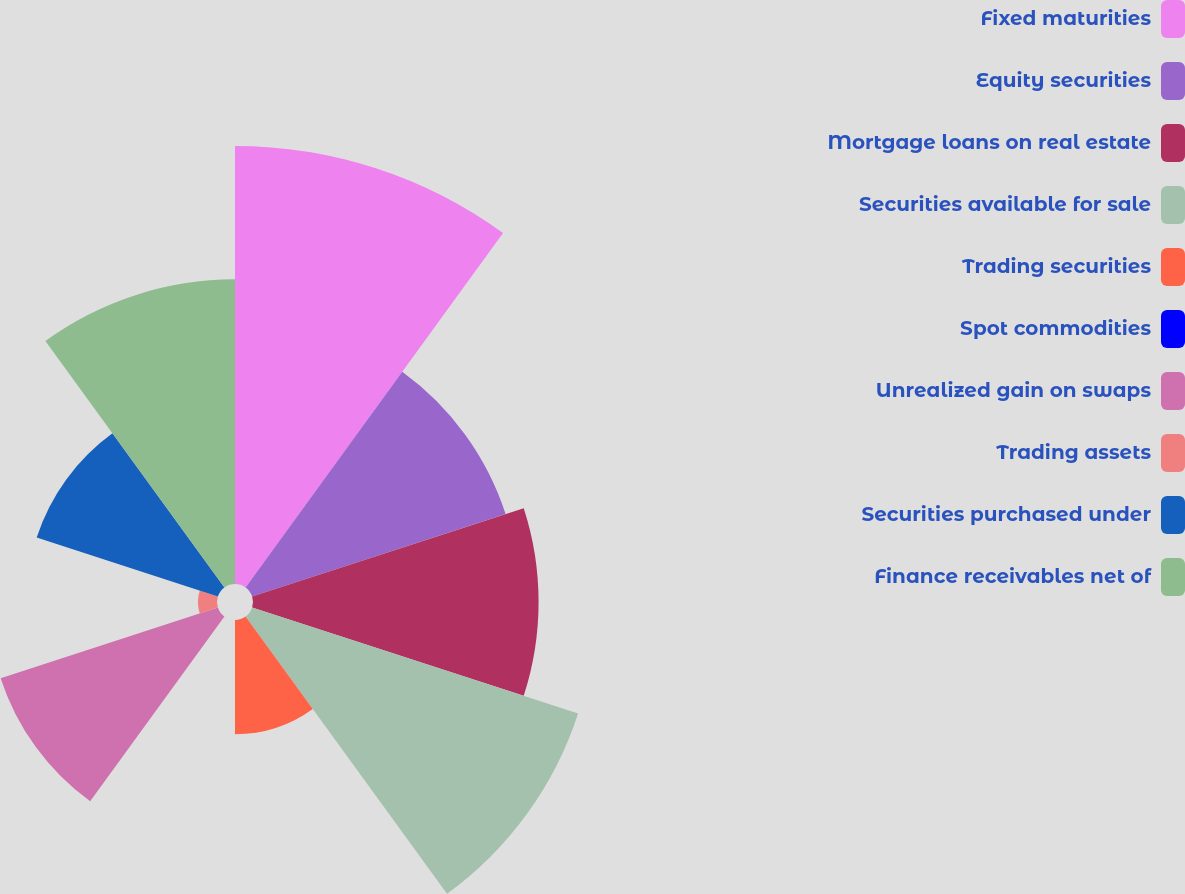Convert chart to OTSL. <chart><loc_0><loc_0><loc_500><loc_500><pie_chart><fcel>Fixed maturities<fcel>Equity securities<fcel>Mortgage loans on real estate<fcel>Securities available for sale<fcel>Trading securities<fcel>Spot commodities<fcel>Unrealized gain on swaps<fcel>Trading assets<fcel>Securities purchased under<fcel>Finance receivables net of<nl><fcel>20.0%<fcel>12.17%<fcel>13.04%<fcel>15.65%<fcel>5.22%<fcel>0.0%<fcel>10.43%<fcel>0.87%<fcel>8.7%<fcel>13.91%<nl></chart> 